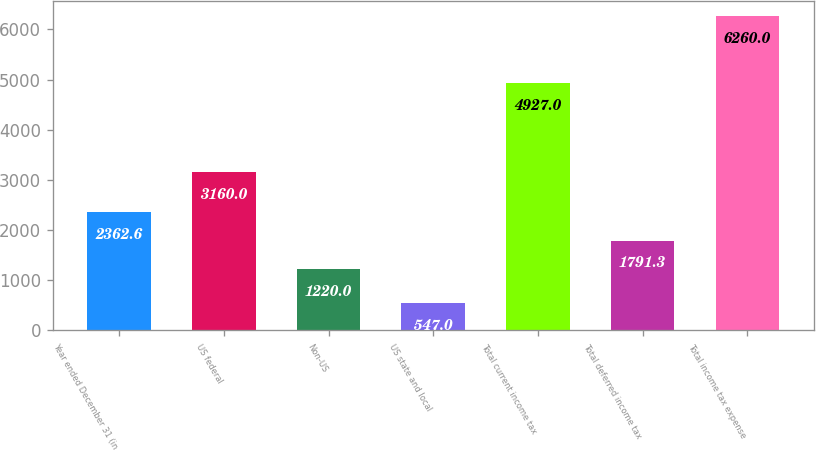<chart> <loc_0><loc_0><loc_500><loc_500><bar_chart><fcel>Year ended December 31 (in<fcel>US federal<fcel>Non-US<fcel>US state and local<fcel>Total current income tax<fcel>Total deferred income tax<fcel>Total income tax expense<nl><fcel>2362.6<fcel>3160<fcel>1220<fcel>547<fcel>4927<fcel>1791.3<fcel>6260<nl></chart> 